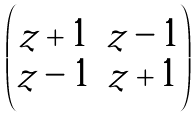<formula> <loc_0><loc_0><loc_500><loc_500>\begin{pmatrix} z + 1 & z - 1 \\ z - 1 & z + 1 \end{pmatrix}</formula> 